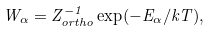<formula> <loc_0><loc_0><loc_500><loc_500>W _ { \alpha } = Z ^ { - 1 } _ { o r t h o } \exp ( - E _ { \alpha } / k T ) ,</formula> 